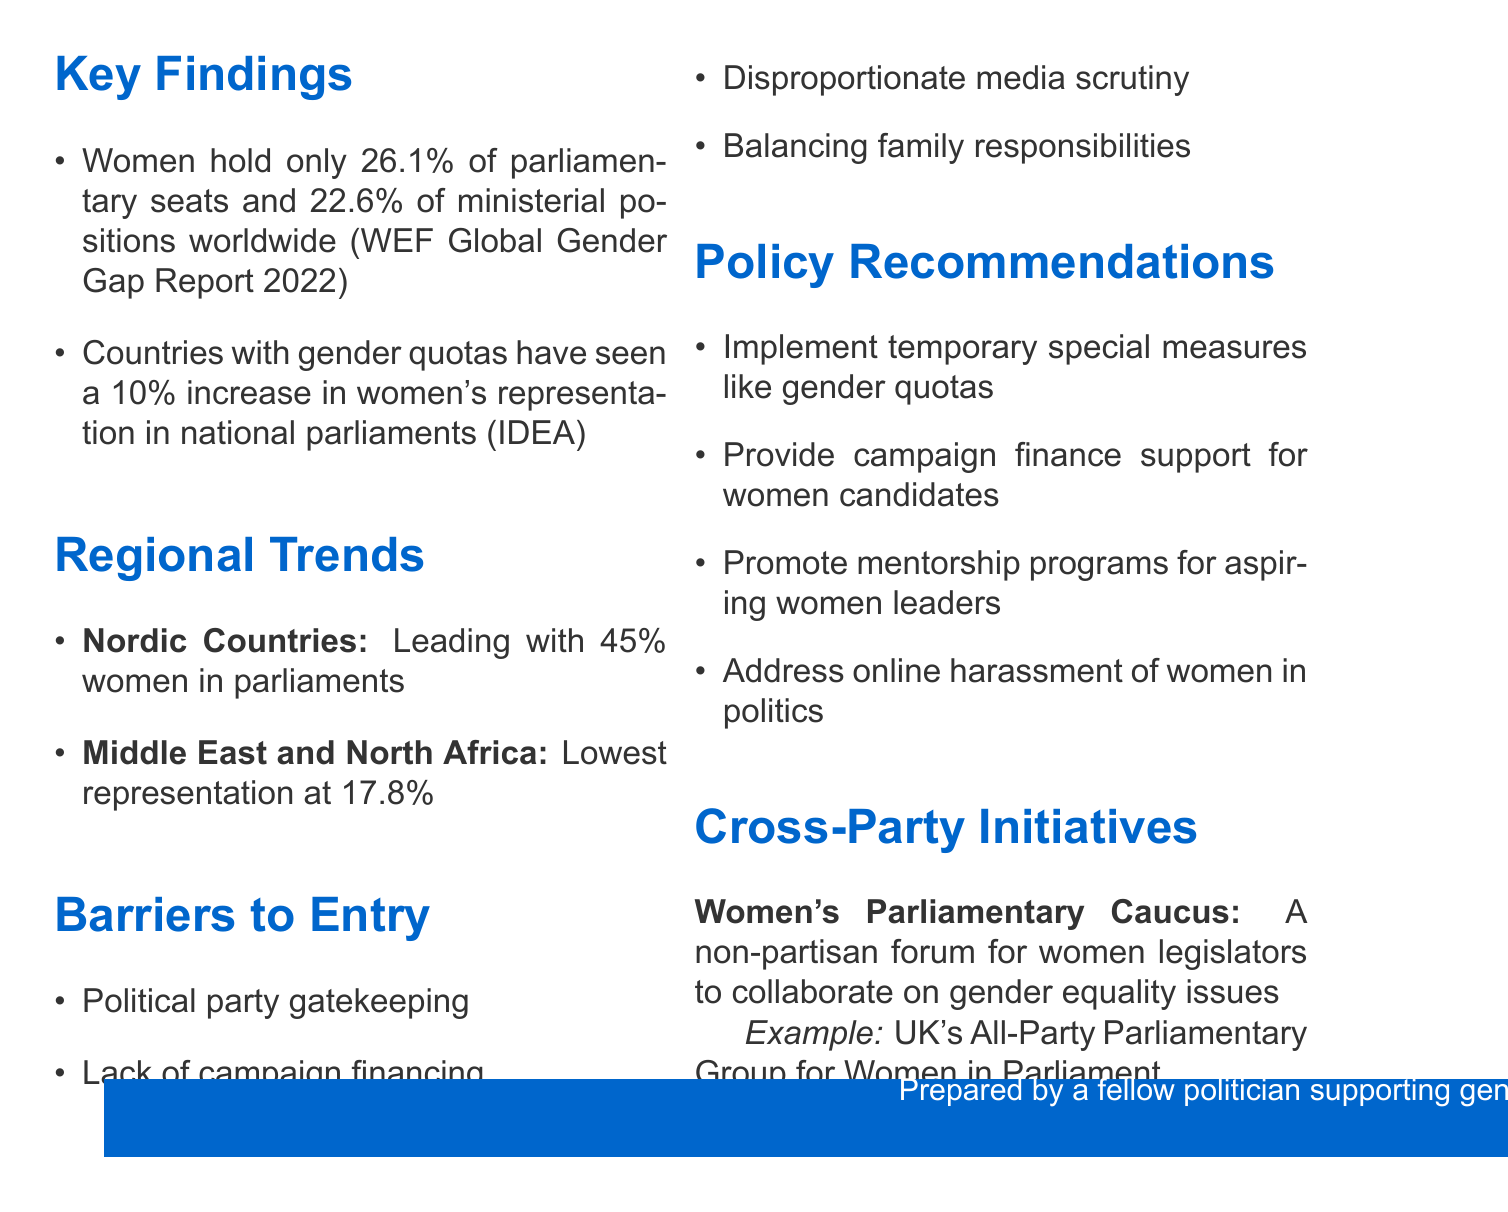What percentage of parliamentary seats do women hold worldwide? The document states that women hold 26.1% of parliamentary seats globally.
Answer: 26.1% What notable example is given for the Nordic countries? The document mentions Finland's all-women led coalition government in 2019 as a notable example.
Answer: Finland's all-women led coalition government in 2019 Which region has the lowest representation of women in political leadership? According to the document, the Middle East and North Africa have the lowest representation at 17.8%.
Answer: Middle East and North Africa How much increase in women's representation is seen in countries with gender quotas? The document indicates a 10% increase in women's representation in national parliaments is observed.
Answer: 10% What is one of the barriers to entry for women in politics listed in the document? The document provides several barriers, one of them being political party gatekeeping.
Answer: Political party gatekeeping What is the name of the non-partisan forum for women legislators mentioned in the document? The document refers to the forum as the Women's Parliamentary Caucus.
Answer: Women's Parliamentary Caucus What type of measures does the document recommend to improve gender representation? The document suggests implementing temporary special measures like gender quotas.
Answer: Gender quotas What percentage of ministerial positions do women hold worldwide? The document states that women hold 22.6% of ministerial positions globally.
Answer: 22.6% 